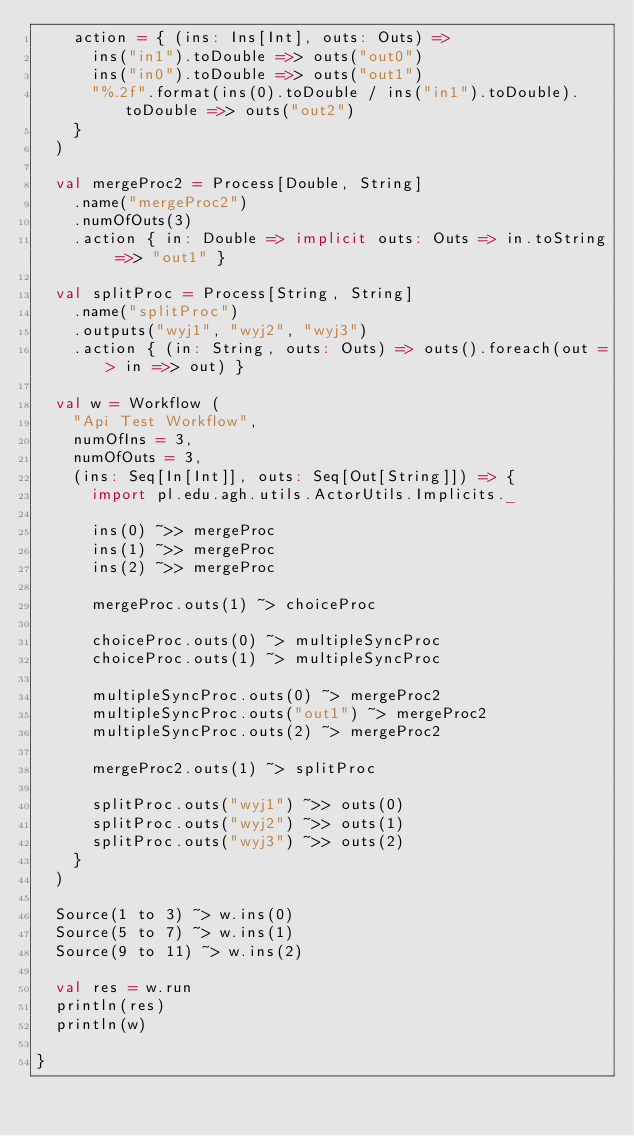Convert code to text. <code><loc_0><loc_0><loc_500><loc_500><_Scala_>    action = { (ins: Ins[Int], outs: Outs) =>
      ins("in1").toDouble =>> outs("out0")
      ins("in0").toDouble =>> outs("out1")
      "%.2f".format(ins(0).toDouble / ins("in1").toDouble).toDouble =>> outs("out2")
    }
  )

  val mergeProc2 = Process[Double, String]
    .name("mergeProc2")
    .numOfOuts(3)
    .action { in: Double => implicit outs: Outs => in.toString =>> "out1" }

  val splitProc = Process[String, String]
    .name("splitProc")
    .outputs("wyj1", "wyj2", "wyj3")
    .action { (in: String, outs: Outs) => outs().foreach(out => in =>> out) }

  val w = Workflow (
    "Api Test Workflow",
    numOfIns = 3,
    numOfOuts = 3,
    (ins: Seq[In[Int]], outs: Seq[Out[String]]) => {
      import pl.edu.agh.utils.ActorUtils.Implicits._

      ins(0) ~>> mergeProc
      ins(1) ~>> mergeProc
      ins(2) ~>> mergeProc

      mergeProc.outs(1) ~> choiceProc

      choiceProc.outs(0) ~> multipleSyncProc
      choiceProc.outs(1) ~> multipleSyncProc

      multipleSyncProc.outs(0) ~> mergeProc2
      multipleSyncProc.outs("out1") ~> mergeProc2
      multipleSyncProc.outs(2) ~> mergeProc2

      mergeProc2.outs(1) ~> splitProc

      splitProc.outs("wyj1") ~>> outs(0)
      splitProc.outs("wyj2") ~>> outs(1)
      splitProc.outs("wyj3") ~>> outs(2)
    }
  )

  Source(1 to 3) ~> w.ins(0)
  Source(5 to 7) ~> w.ins(1)
  Source(9 to 11) ~> w.ins(2)

  val res = w.run
  println(res)
  println(w)

}
</code> 